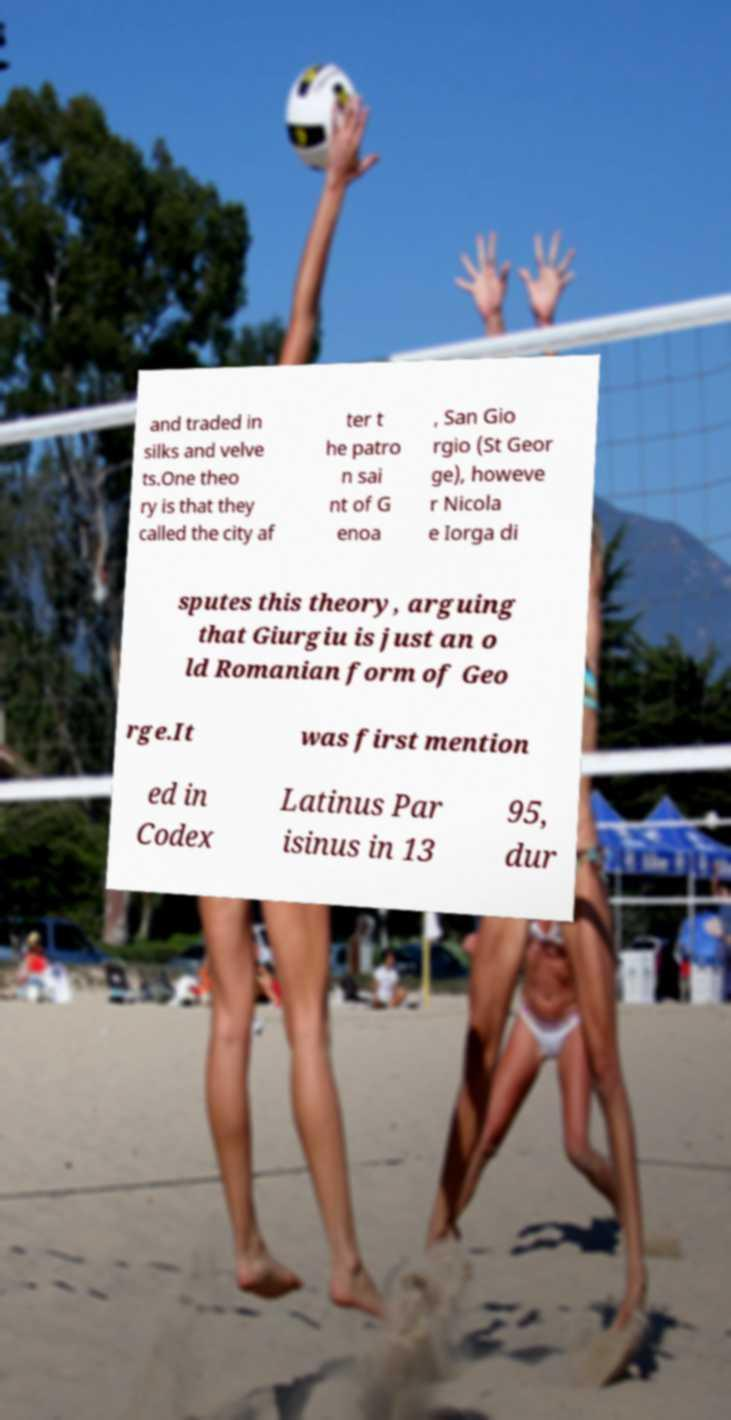Could you extract and type out the text from this image? and traded in silks and velve ts.One theo ry is that they called the city af ter t he patro n sai nt of G enoa , San Gio rgio (St Geor ge), howeve r Nicola e Iorga di sputes this theory, arguing that Giurgiu is just an o ld Romanian form of Geo rge.It was first mention ed in Codex Latinus Par isinus in 13 95, dur 